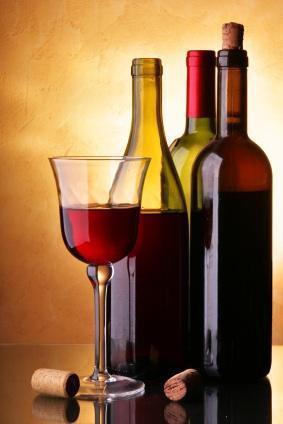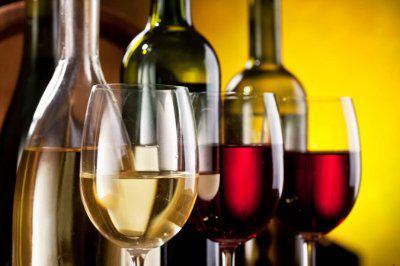The first image is the image on the left, the second image is the image on the right. Considering the images on both sides, is "there are at least seven wine bottles in the image on the left" valid? Answer yes or no. No. The first image is the image on the left, the second image is the image on the right. Examine the images to the left and right. Is the description "An image shows a horizontal row of at least 7 bottles, with no space between bottles." accurate? Answer yes or no. No. 